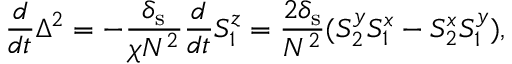<formula> <loc_0><loc_0><loc_500><loc_500>\frac { d } { d t } \Delta ^ { 2 } = - \frac { \delta _ { s } } { \chi N ^ { 2 } } \frac { d } { d t } S _ { 1 } ^ { z } = \frac { 2 \delta _ { s } } { N ^ { 2 } } ( S _ { 2 } ^ { y } S _ { 1 } ^ { x } - S _ { 2 } ^ { x } S _ { 1 } ^ { y } ) ,</formula> 